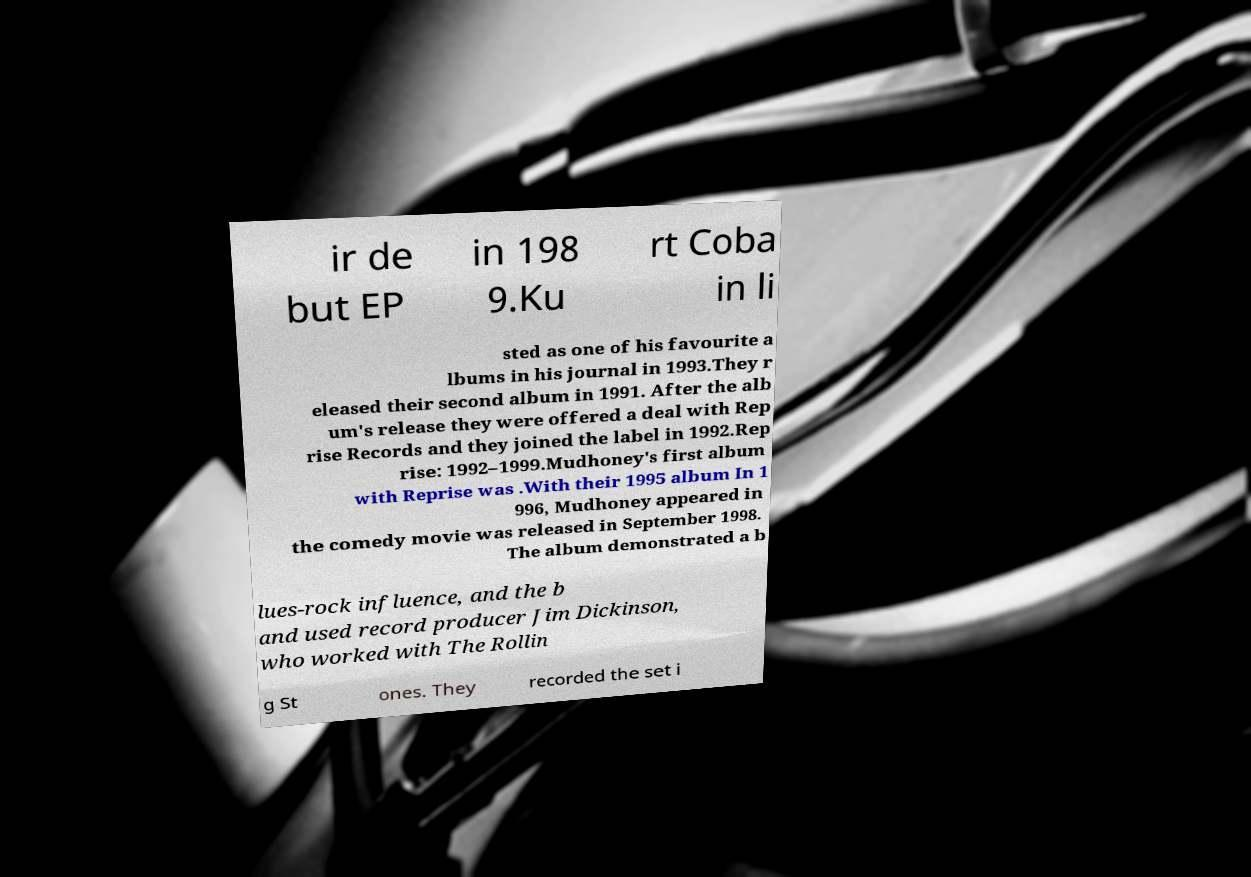Can you read and provide the text displayed in the image?This photo seems to have some interesting text. Can you extract and type it out for me? ir de but EP in 198 9.Ku rt Coba in li sted as one of his favourite a lbums in his journal in 1993.They r eleased their second album in 1991. After the alb um's release they were offered a deal with Rep rise Records and they joined the label in 1992.Rep rise: 1992–1999.Mudhoney's first album with Reprise was .With their 1995 album In 1 996, Mudhoney appeared in the comedy movie was released in September 1998. The album demonstrated a b lues-rock influence, and the b and used record producer Jim Dickinson, who worked with The Rollin g St ones. They recorded the set i 